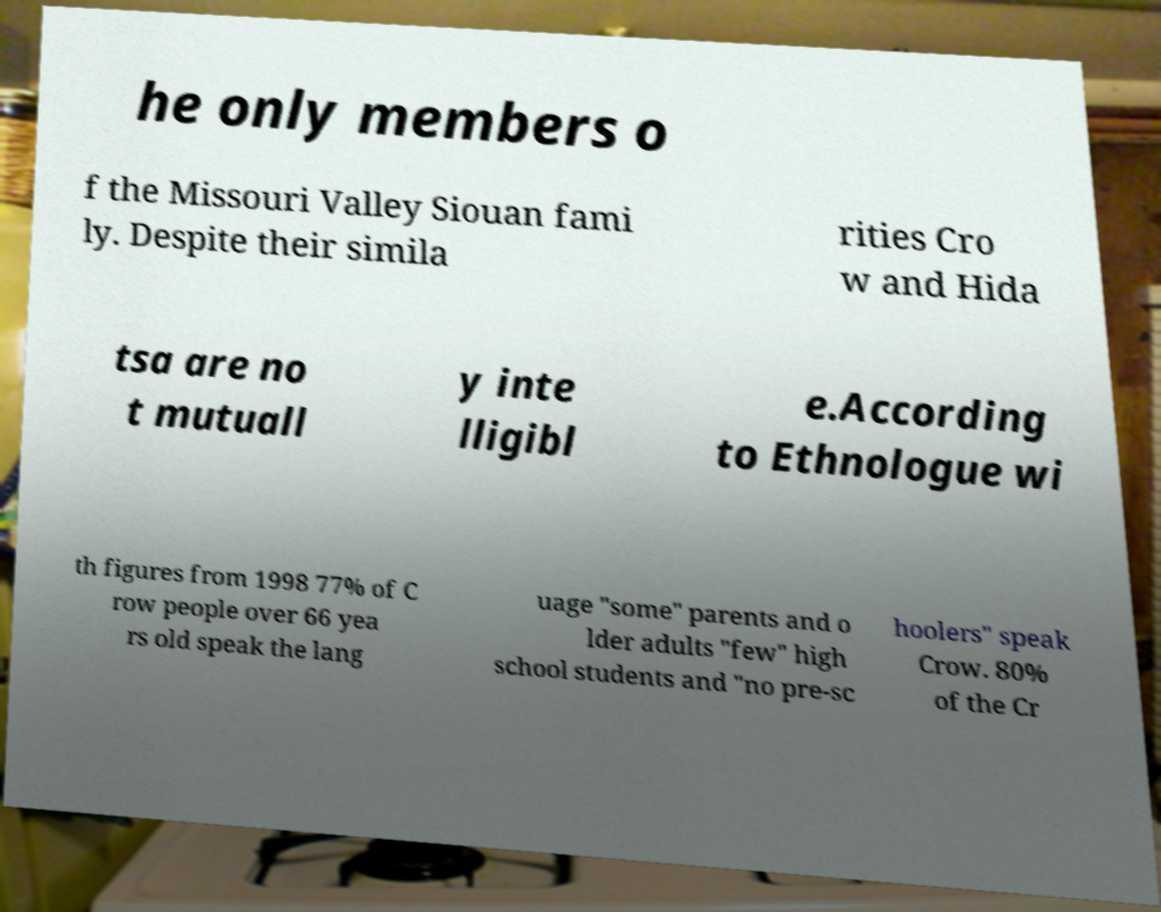I need the written content from this picture converted into text. Can you do that? he only members o f the Missouri Valley Siouan fami ly. Despite their simila rities Cro w and Hida tsa are no t mutuall y inte lligibl e.According to Ethnologue wi th figures from 1998 77% of C row people over 66 yea rs old speak the lang uage "some" parents and o lder adults "few" high school students and "no pre-sc hoolers" speak Crow. 80% of the Cr 